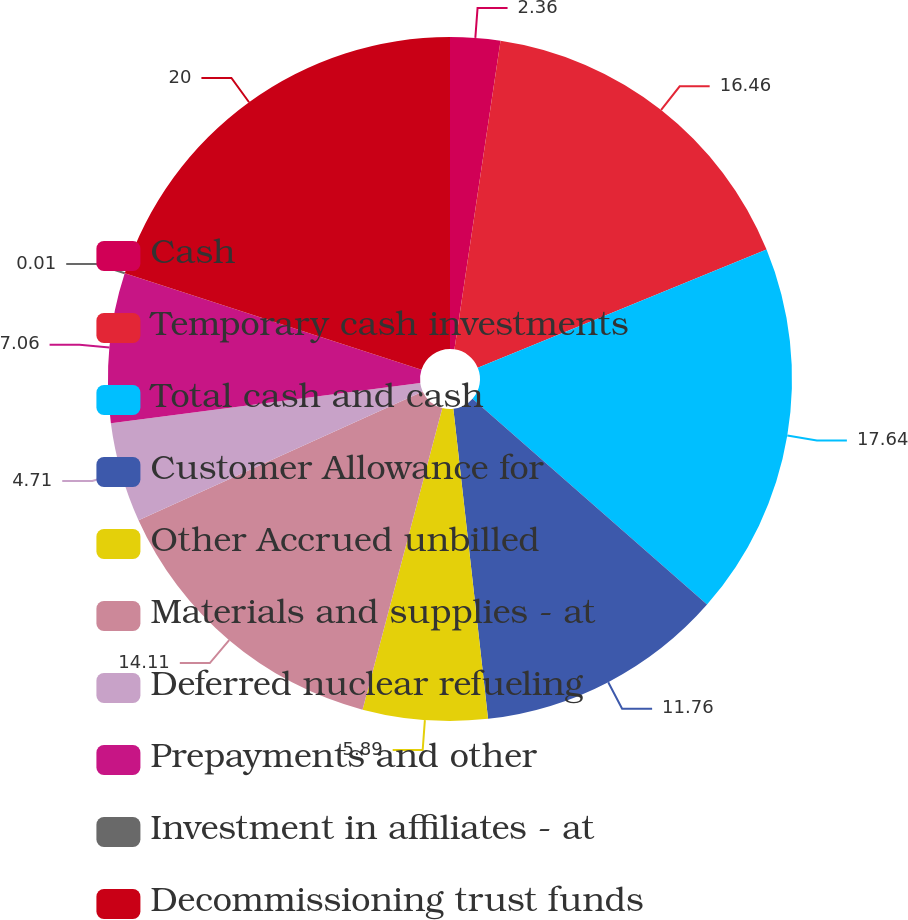<chart> <loc_0><loc_0><loc_500><loc_500><pie_chart><fcel>Cash<fcel>Temporary cash investments<fcel>Total cash and cash<fcel>Customer Allowance for<fcel>Other Accrued unbilled<fcel>Materials and supplies - at<fcel>Deferred nuclear refueling<fcel>Prepayments and other<fcel>Investment in affiliates - at<fcel>Decommissioning trust funds<nl><fcel>2.36%<fcel>16.46%<fcel>17.64%<fcel>11.76%<fcel>5.89%<fcel>14.11%<fcel>4.71%<fcel>7.06%<fcel>0.01%<fcel>19.99%<nl></chart> 